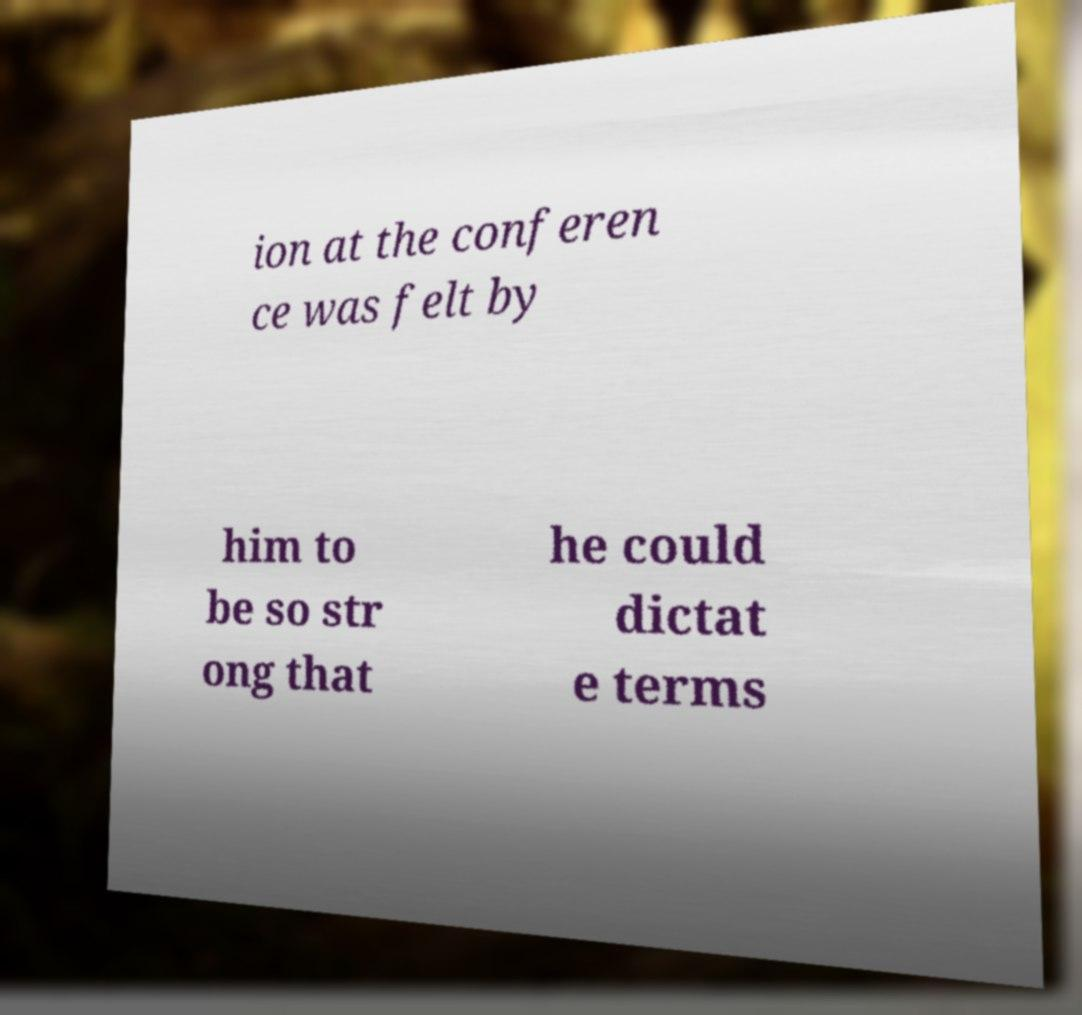Please read and relay the text visible in this image. What does it say? ion at the conferen ce was felt by him to be so str ong that he could dictat e terms 